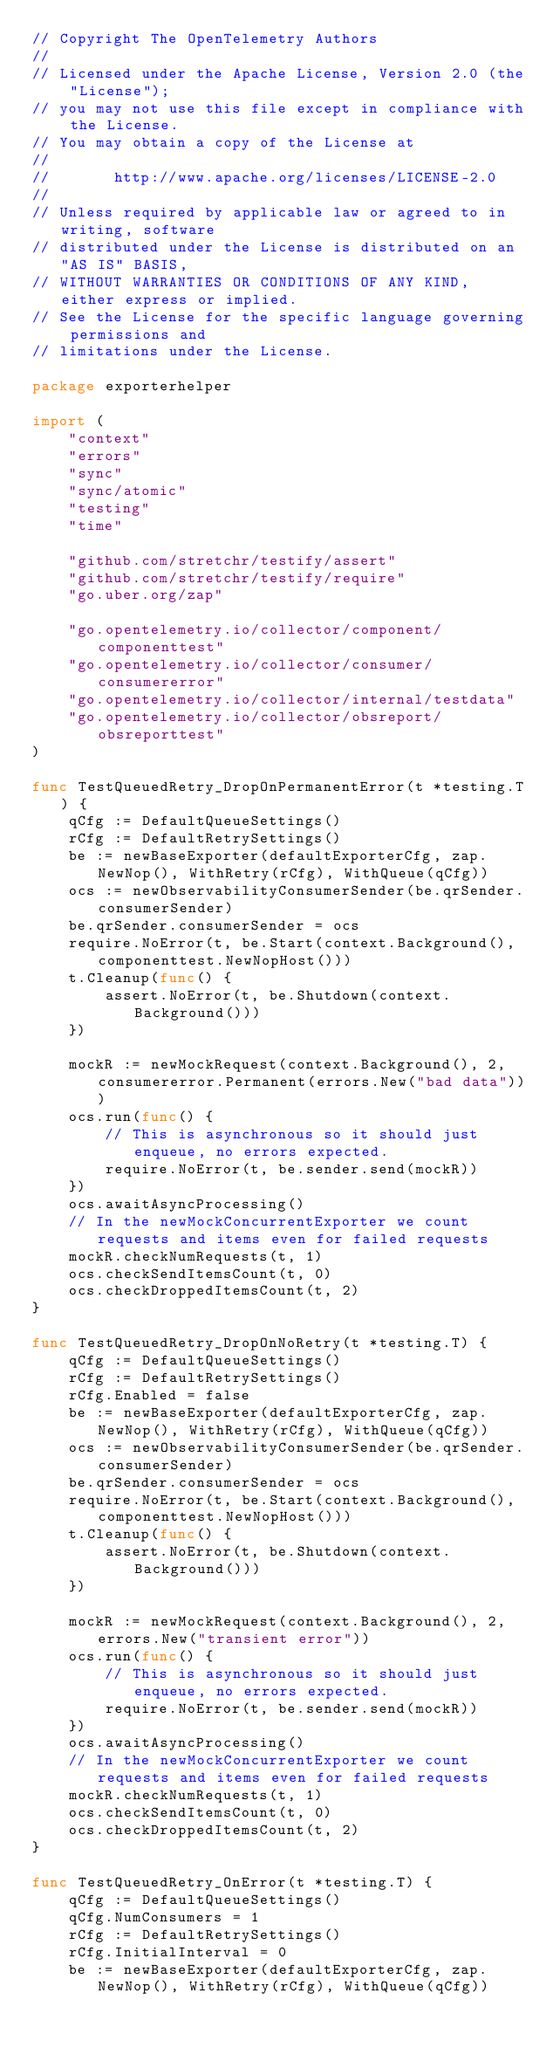<code> <loc_0><loc_0><loc_500><loc_500><_Go_>// Copyright The OpenTelemetry Authors
//
// Licensed under the Apache License, Version 2.0 (the "License");
// you may not use this file except in compliance with the License.
// You may obtain a copy of the License at
//
//       http://www.apache.org/licenses/LICENSE-2.0
//
// Unless required by applicable law or agreed to in writing, software
// distributed under the License is distributed on an "AS IS" BASIS,
// WITHOUT WARRANTIES OR CONDITIONS OF ANY KIND, either express or implied.
// See the License for the specific language governing permissions and
// limitations under the License.

package exporterhelper

import (
	"context"
	"errors"
	"sync"
	"sync/atomic"
	"testing"
	"time"

	"github.com/stretchr/testify/assert"
	"github.com/stretchr/testify/require"
	"go.uber.org/zap"

	"go.opentelemetry.io/collector/component/componenttest"
	"go.opentelemetry.io/collector/consumer/consumererror"
	"go.opentelemetry.io/collector/internal/testdata"
	"go.opentelemetry.io/collector/obsreport/obsreporttest"
)

func TestQueuedRetry_DropOnPermanentError(t *testing.T) {
	qCfg := DefaultQueueSettings()
	rCfg := DefaultRetrySettings()
	be := newBaseExporter(defaultExporterCfg, zap.NewNop(), WithRetry(rCfg), WithQueue(qCfg))
	ocs := newObservabilityConsumerSender(be.qrSender.consumerSender)
	be.qrSender.consumerSender = ocs
	require.NoError(t, be.Start(context.Background(), componenttest.NewNopHost()))
	t.Cleanup(func() {
		assert.NoError(t, be.Shutdown(context.Background()))
	})

	mockR := newMockRequest(context.Background(), 2, consumererror.Permanent(errors.New("bad data")))
	ocs.run(func() {
		// This is asynchronous so it should just enqueue, no errors expected.
		require.NoError(t, be.sender.send(mockR))
	})
	ocs.awaitAsyncProcessing()
	// In the newMockConcurrentExporter we count requests and items even for failed requests
	mockR.checkNumRequests(t, 1)
	ocs.checkSendItemsCount(t, 0)
	ocs.checkDroppedItemsCount(t, 2)
}

func TestQueuedRetry_DropOnNoRetry(t *testing.T) {
	qCfg := DefaultQueueSettings()
	rCfg := DefaultRetrySettings()
	rCfg.Enabled = false
	be := newBaseExporter(defaultExporterCfg, zap.NewNop(), WithRetry(rCfg), WithQueue(qCfg))
	ocs := newObservabilityConsumerSender(be.qrSender.consumerSender)
	be.qrSender.consumerSender = ocs
	require.NoError(t, be.Start(context.Background(), componenttest.NewNopHost()))
	t.Cleanup(func() {
		assert.NoError(t, be.Shutdown(context.Background()))
	})

	mockR := newMockRequest(context.Background(), 2, errors.New("transient error"))
	ocs.run(func() {
		// This is asynchronous so it should just enqueue, no errors expected.
		require.NoError(t, be.sender.send(mockR))
	})
	ocs.awaitAsyncProcessing()
	// In the newMockConcurrentExporter we count requests and items even for failed requests
	mockR.checkNumRequests(t, 1)
	ocs.checkSendItemsCount(t, 0)
	ocs.checkDroppedItemsCount(t, 2)
}

func TestQueuedRetry_OnError(t *testing.T) {
	qCfg := DefaultQueueSettings()
	qCfg.NumConsumers = 1
	rCfg := DefaultRetrySettings()
	rCfg.InitialInterval = 0
	be := newBaseExporter(defaultExporterCfg, zap.NewNop(), WithRetry(rCfg), WithQueue(qCfg))</code> 